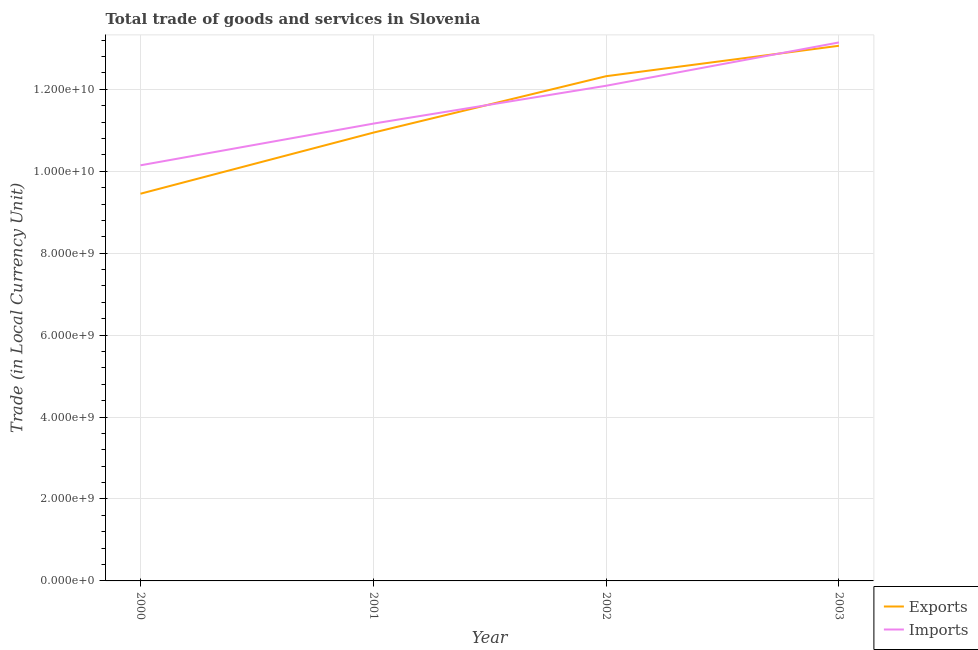How many different coloured lines are there?
Your answer should be compact. 2. Does the line corresponding to imports of goods and services intersect with the line corresponding to export of goods and services?
Ensure brevity in your answer.  Yes. Is the number of lines equal to the number of legend labels?
Give a very brief answer. Yes. What is the imports of goods and services in 2003?
Ensure brevity in your answer.  1.31e+1. Across all years, what is the maximum imports of goods and services?
Offer a very short reply. 1.31e+1. Across all years, what is the minimum imports of goods and services?
Offer a very short reply. 1.01e+1. In which year was the export of goods and services maximum?
Offer a very short reply. 2003. In which year was the imports of goods and services minimum?
Your answer should be compact. 2000. What is the total imports of goods and services in the graph?
Keep it short and to the point. 4.65e+1. What is the difference between the imports of goods and services in 2000 and that in 2001?
Give a very brief answer. -1.02e+09. What is the difference between the export of goods and services in 2001 and the imports of goods and services in 2002?
Offer a terse response. -1.14e+09. What is the average imports of goods and services per year?
Provide a short and direct response. 1.16e+1. In the year 2003, what is the difference between the imports of goods and services and export of goods and services?
Offer a very short reply. 8.13e+07. In how many years, is the imports of goods and services greater than 6400000000 LCU?
Your response must be concise. 4. What is the ratio of the imports of goods and services in 2002 to that in 2003?
Make the answer very short. 0.92. Is the imports of goods and services in 2001 less than that in 2002?
Provide a short and direct response. Yes. Is the difference between the imports of goods and services in 2000 and 2001 greater than the difference between the export of goods and services in 2000 and 2001?
Your response must be concise. Yes. What is the difference between the highest and the second highest imports of goods and services?
Ensure brevity in your answer.  1.06e+09. What is the difference between the highest and the lowest export of goods and services?
Make the answer very short. 3.61e+09. Is the export of goods and services strictly greater than the imports of goods and services over the years?
Your answer should be compact. No. How many lines are there?
Keep it short and to the point. 2. How many years are there in the graph?
Offer a terse response. 4. What is the difference between two consecutive major ticks on the Y-axis?
Your answer should be compact. 2.00e+09. Does the graph contain any zero values?
Your response must be concise. No. What is the title of the graph?
Provide a succinct answer. Total trade of goods and services in Slovenia. Does "Birth rate" appear as one of the legend labels in the graph?
Offer a terse response. No. What is the label or title of the Y-axis?
Make the answer very short. Trade (in Local Currency Unit). What is the Trade (in Local Currency Unit) of Exports in 2000?
Keep it short and to the point. 9.45e+09. What is the Trade (in Local Currency Unit) of Imports in 2000?
Make the answer very short. 1.01e+1. What is the Trade (in Local Currency Unit) in Exports in 2001?
Provide a succinct answer. 1.09e+1. What is the Trade (in Local Currency Unit) of Imports in 2001?
Your answer should be compact. 1.12e+1. What is the Trade (in Local Currency Unit) of Exports in 2002?
Offer a very short reply. 1.23e+1. What is the Trade (in Local Currency Unit) of Imports in 2002?
Your answer should be compact. 1.21e+1. What is the Trade (in Local Currency Unit) of Exports in 2003?
Ensure brevity in your answer.  1.31e+1. What is the Trade (in Local Currency Unit) in Imports in 2003?
Make the answer very short. 1.31e+1. Across all years, what is the maximum Trade (in Local Currency Unit) in Exports?
Your answer should be very brief. 1.31e+1. Across all years, what is the maximum Trade (in Local Currency Unit) in Imports?
Provide a short and direct response. 1.31e+1. Across all years, what is the minimum Trade (in Local Currency Unit) of Exports?
Offer a terse response. 9.45e+09. Across all years, what is the minimum Trade (in Local Currency Unit) of Imports?
Offer a terse response. 1.01e+1. What is the total Trade (in Local Currency Unit) in Exports in the graph?
Offer a terse response. 4.58e+1. What is the total Trade (in Local Currency Unit) in Imports in the graph?
Your answer should be compact. 4.65e+1. What is the difference between the Trade (in Local Currency Unit) in Exports in 2000 and that in 2001?
Offer a terse response. -1.49e+09. What is the difference between the Trade (in Local Currency Unit) of Imports in 2000 and that in 2001?
Your answer should be compact. -1.02e+09. What is the difference between the Trade (in Local Currency Unit) in Exports in 2000 and that in 2002?
Your answer should be very brief. -2.87e+09. What is the difference between the Trade (in Local Currency Unit) of Imports in 2000 and that in 2002?
Give a very brief answer. -1.94e+09. What is the difference between the Trade (in Local Currency Unit) of Exports in 2000 and that in 2003?
Your answer should be very brief. -3.61e+09. What is the difference between the Trade (in Local Currency Unit) in Imports in 2000 and that in 2003?
Your response must be concise. -3.00e+09. What is the difference between the Trade (in Local Currency Unit) of Exports in 2001 and that in 2002?
Offer a terse response. -1.38e+09. What is the difference between the Trade (in Local Currency Unit) of Imports in 2001 and that in 2002?
Provide a succinct answer. -9.24e+08. What is the difference between the Trade (in Local Currency Unit) of Exports in 2001 and that in 2003?
Make the answer very short. -2.12e+09. What is the difference between the Trade (in Local Currency Unit) in Imports in 2001 and that in 2003?
Your answer should be compact. -1.98e+09. What is the difference between the Trade (in Local Currency Unit) in Exports in 2002 and that in 2003?
Offer a terse response. -7.43e+08. What is the difference between the Trade (in Local Currency Unit) in Imports in 2002 and that in 2003?
Offer a terse response. -1.06e+09. What is the difference between the Trade (in Local Currency Unit) in Exports in 2000 and the Trade (in Local Currency Unit) in Imports in 2001?
Keep it short and to the point. -1.71e+09. What is the difference between the Trade (in Local Currency Unit) in Exports in 2000 and the Trade (in Local Currency Unit) in Imports in 2002?
Ensure brevity in your answer.  -2.64e+09. What is the difference between the Trade (in Local Currency Unit) of Exports in 2000 and the Trade (in Local Currency Unit) of Imports in 2003?
Your response must be concise. -3.69e+09. What is the difference between the Trade (in Local Currency Unit) of Exports in 2001 and the Trade (in Local Currency Unit) of Imports in 2002?
Make the answer very short. -1.14e+09. What is the difference between the Trade (in Local Currency Unit) in Exports in 2001 and the Trade (in Local Currency Unit) in Imports in 2003?
Provide a short and direct response. -2.20e+09. What is the difference between the Trade (in Local Currency Unit) of Exports in 2002 and the Trade (in Local Currency Unit) of Imports in 2003?
Give a very brief answer. -8.24e+08. What is the average Trade (in Local Currency Unit) in Exports per year?
Provide a short and direct response. 1.14e+1. What is the average Trade (in Local Currency Unit) in Imports per year?
Offer a very short reply. 1.16e+1. In the year 2000, what is the difference between the Trade (in Local Currency Unit) in Exports and Trade (in Local Currency Unit) in Imports?
Give a very brief answer. -6.93e+08. In the year 2001, what is the difference between the Trade (in Local Currency Unit) of Exports and Trade (in Local Currency Unit) of Imports?
Offer a terse response. -2.20e+08. In the year 2002, what is the difference between the Trade (in Local Currency Unit) in Exports and Trade (in Local Currency Unit) in Imports?
Make the answer very short. 2.33e+08. In the year 2003, what is the difference between the Trade (in Local Currency Unit) in Exports and Trade (in Local Currency Unit) in Imports?
Provide a succinct answer. -8.13e+07. What is the ratio of the Trade (in Local Currency Unit) in Exports in 2000 to that in 2001?
Your answer should be compact. 0.86. What is the ratio of the Trade (in Local Currency Unit) of Imports in 2000 to that in 2001?
Your answer should be very brief. 0.91. What is the ratio of the Trade (in Local Currency Unit) of Exports in 2000 to that in 2002?
Make the answer very short. 0.77. What is the ratio of the Trade (in Local Currency Unit) of Imports in 2000 to that in 2002?
Your answer should be very brief. 0.84. What is the ratio of the Trade (in Local Currency Unit) in Exports in 2000 to that in 2003?
Provide a short and direct response. 0.72. What is the ratio of the Trade (in Local Currency Unit) in Imports in 2000 to that in 2003?
Your response must be concise. 0.77. What is the ratio of the Trade (in Local Currency Unit) of Exports in 2001 to that in 2002?
Keep it short and to the point. 0.89. What is the ratio of the Trade (in Local Currency Unit) of Imports in 2001 to that in 2002?
Offer a very short reply. 0.92. What is the ratio of the Trade (in Local Currency Unit) in Exports in 2001 to that in 2003?
Offer a terse response. 0.84. What is the ratio of the Trade (in Local Currency Unit) in Imports in 2001 to that in 2003?
Your answer should be compact. 0.85. What is the ratio of the Trade (in Local Currency Unit) in Exports in 2002 to that in 2003?
Offer a very short reply. 0.94. What is the ratio of the Trade (in Local Currency Unit) in Imports in 2002 to that in 2003?
Your response must be concise. 0.92. What is the difference between the highest and the second highest Trade (in Local Currency Unit) in Exports?
Your answer should be compact. 7.43e+08. What is the difference between the highest and the second highest Trade (in Local Currency Unit) of Imports?
Your response must be concise. 1.06e+09. What is the difference between the highest and the lowest Trade (in Local Currency Unit) of Exports?
Provide a short and direct response. 3.61e+09. What is the difference between the highest and the lowest Trade (in Local Currency Unit) in Imports?
Keep it short and to the point. 3.00e+09. 